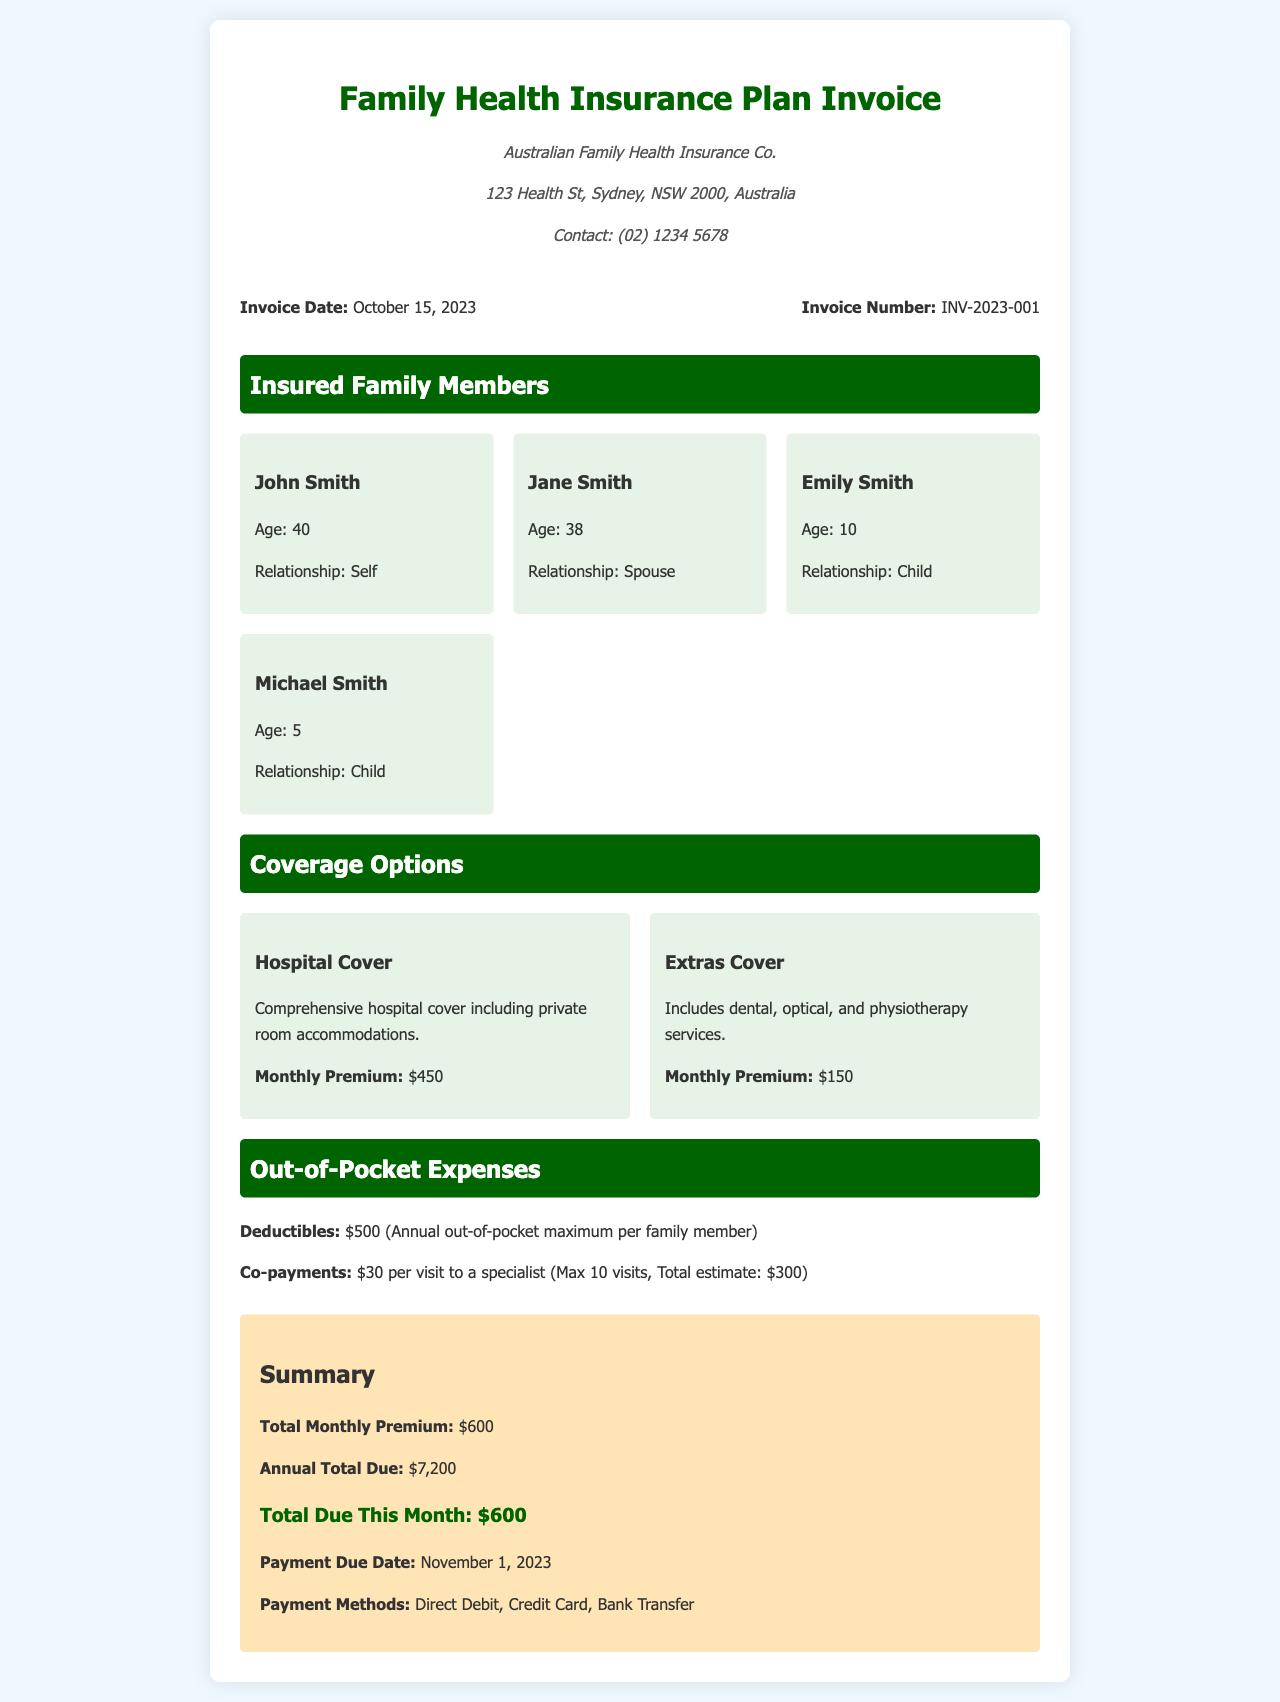What is the name of the insurance provider? The name of the insurance provider is listed at the top of the invoice under provider info.
Answer: Australian Family Health Insurance Co What is the invoice number? The invoice number is mentioned in the invoice details section.
Answer: INV-2023-001 How many members are insured under this plan? The insured family members are listed in their own section of the document.
Answer: Four What is the monthly premium for hospital cover? The monthly premium for hospital cover is stated under the coverage options section.
Answer: $450 What is the total monthly premium? The total monthly premium is summarized at the bottom of the document.
Answer: $600 What is the payment due date? The payment due date is specified in the summary section.
Answer: November 1, 2023 How much is the annual out-of-pocket maximum per family member? The annual out-of-pocket maximum for deductibles is mentioned under out-of-pocket expenses.
Answer: $500 What is the total annual amount due? The total annual amount due is detailed in the summary section.
Answer: $7,200 What are the payment methods offered? The payment methods are found in the summary section of the invoice.
Answer: Direct Debit, Credit Card, Bank Transfer 